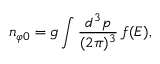<formula> <loc_0><loc_0><loc_500><loc_500>n _ { \varphi 0 } = g \int { \frac { d ^ { 3 } p } { ( 2 \pi ) ^ { 3 } } } \, f ( E ) ,</formula> 